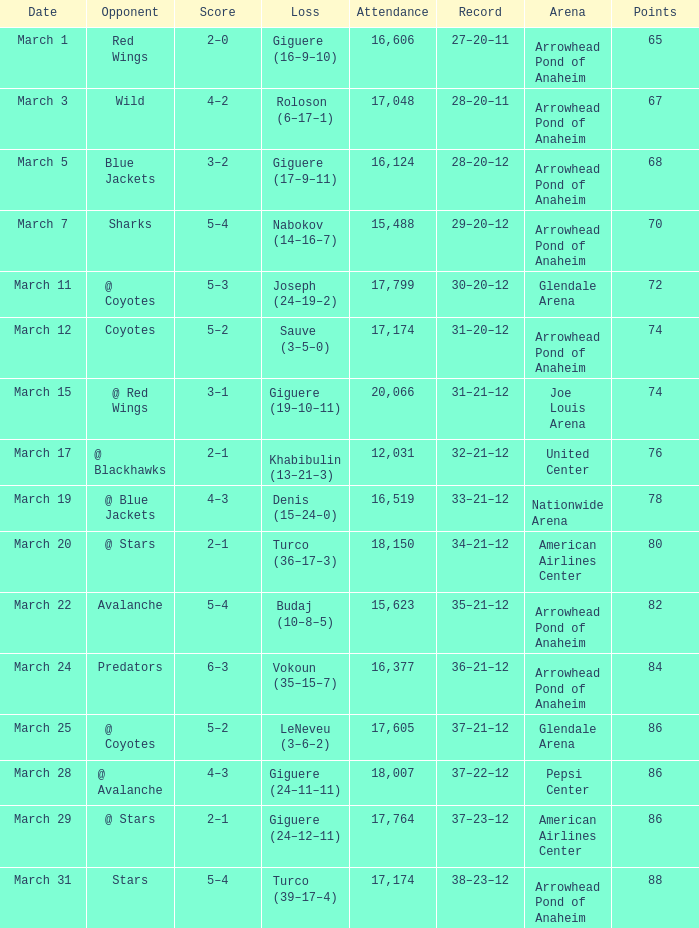What is the Loss of the game at Nationwide Arena with a Score of 4–3? Denis (15–24–0). 